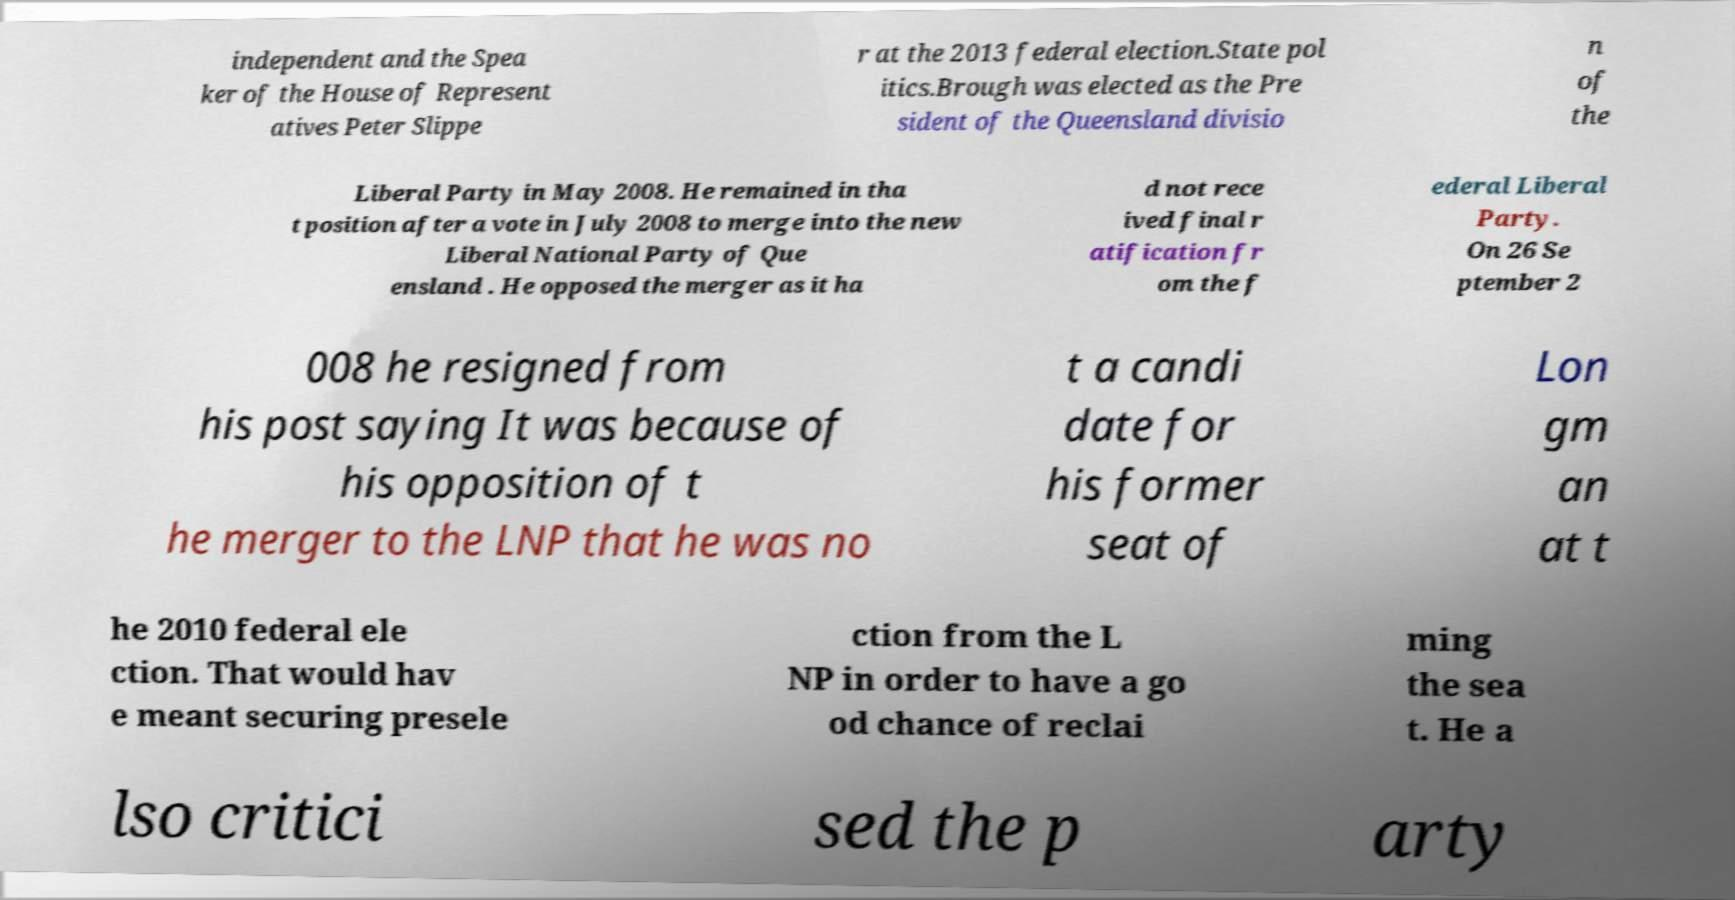Can you read and provide the text displayed in the image?This photo seems to have some interesting text. Can you extract and type it out for me? independent and the Spea ker of the House of Represent atives Peter Slippe r at the 2013 federal election.State pol itics.Brough was elected as the Pre sident of the Queensland divisio n of the Liberal Party in May 2008. He remained in tha t position after a vote in July 2008 to merge into the new Liberal National Party of Que ensland . He opposed the merger as it ha d not rece ived final r atification fr om the f ederal Liberal Party. On 26 Se ptember 2 008 he resigned from his post saying It was because of his opposition of t he merger to the LNP that he was no t a candi date for his former seat of Lon gm an at t he 2010 federal ele ction. That would hav e meant securing presele ction from the L NP in order to have a go od chance of reclai ming the sea t. He a lso critici sed the p arty 